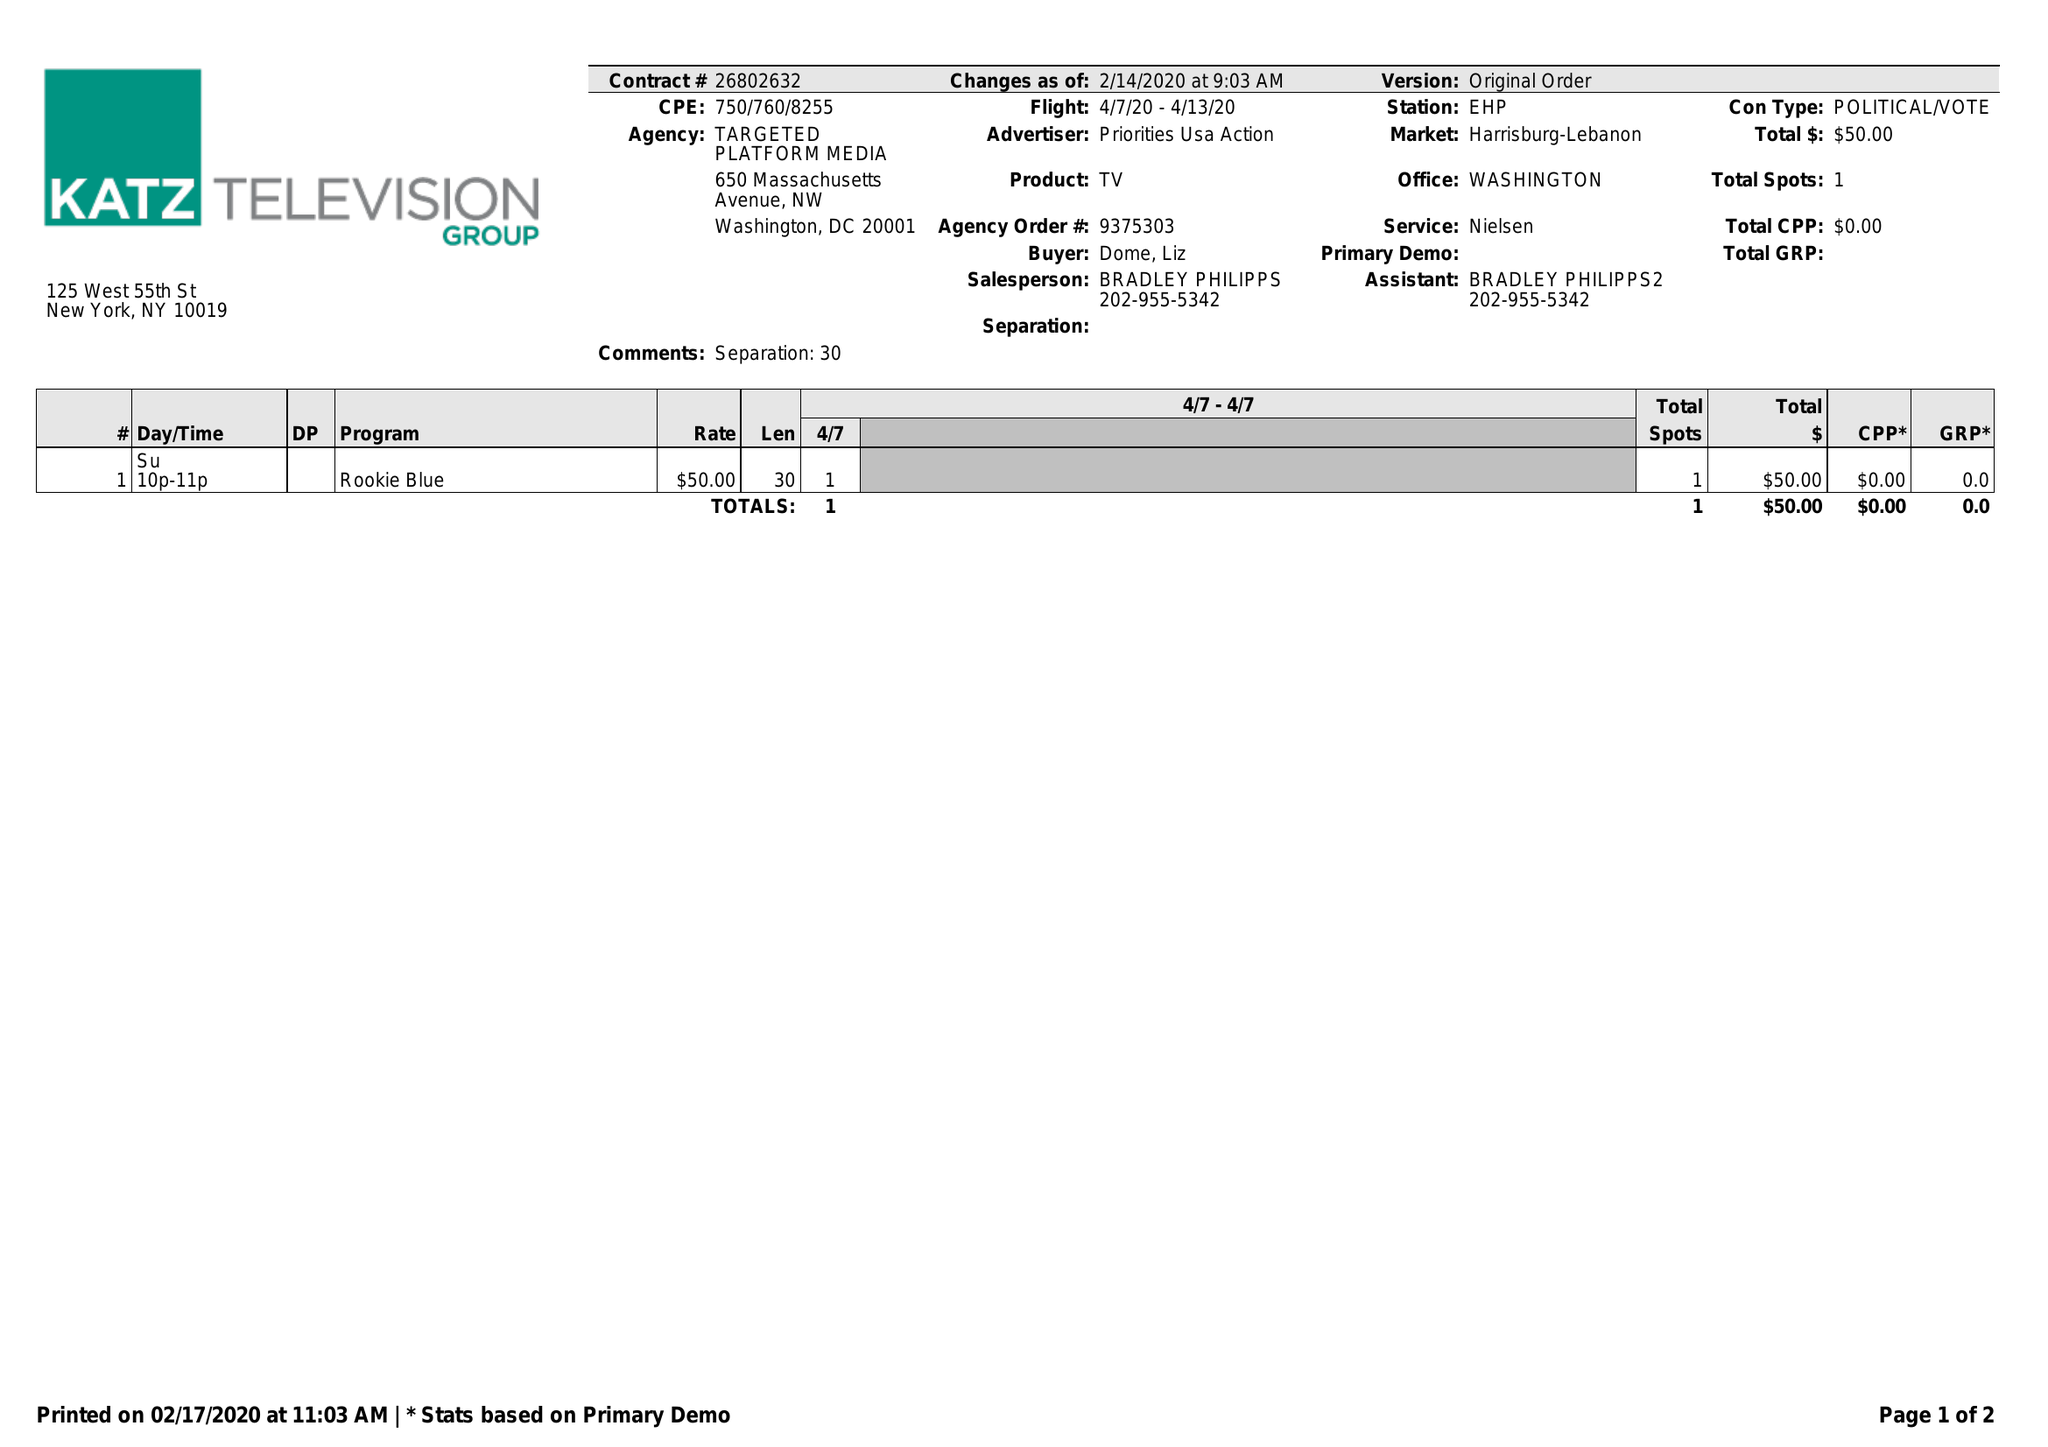What is the value for the flight_from?
Answer the question using a single word or phrase. 04/07/20 